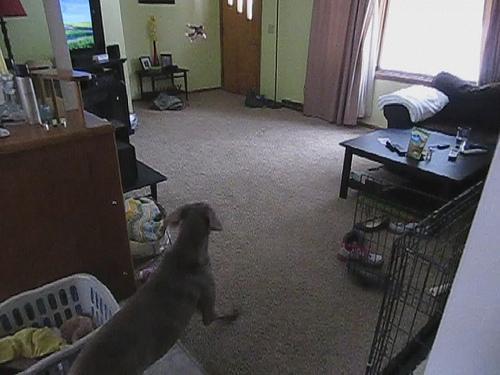How many cages are there?
Give a very brief answer. 1. 